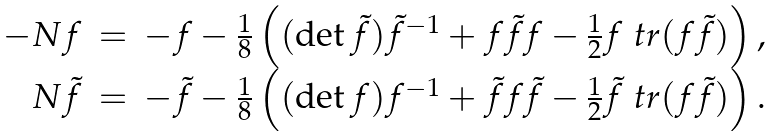<formula> <loc_0><loc_0><loc_500><loc_500>\begin{array} { r c l } - N f & = & - f - \frac { 1 } { 8 } \left ( ( \det \tilde { f } ) \tilde { f } ^ { - 1 } + f \tilde { f } f - \frac { 1 } { 2 } f \ t r ( f \tilde { f } ) \right ) , \\ N \tilde { f } & = & - \tilde { f } - \frac { 1 } { 8 } \left ( ( \det f ) f ^ { - 1 } + \tilde { f } f \tilde { f } - \frac { 1 } { 2 } \tilde { f } \ t r ( f \tilde { f } ) \right ) . \end{array}</formula> 